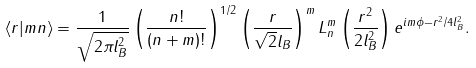Convert formula to latex. <formula><loc_0><loc_0><loc_500><loc_500>\langle { r } | m n \rangle = \frac { 1 } { \sqrt { 2 \pi l _ { B } ^ { 2 } } } \left ( \frac { n ! } { ( n + m ) ! } \right ) ^ { 1 / 2 } \left ( \frac { r } { \sqrt { 2 } l _ { B } } \right ) ^ { m } L ^ { m } _ { n } \left ( \frac { r ^ { 2 } } { 2 l _ { B } ^ { 2 } } \right ) e ^ { i m \phi - r ^ { 2 } / 4 l _ { B } ^ { 2 } } .</formula> 